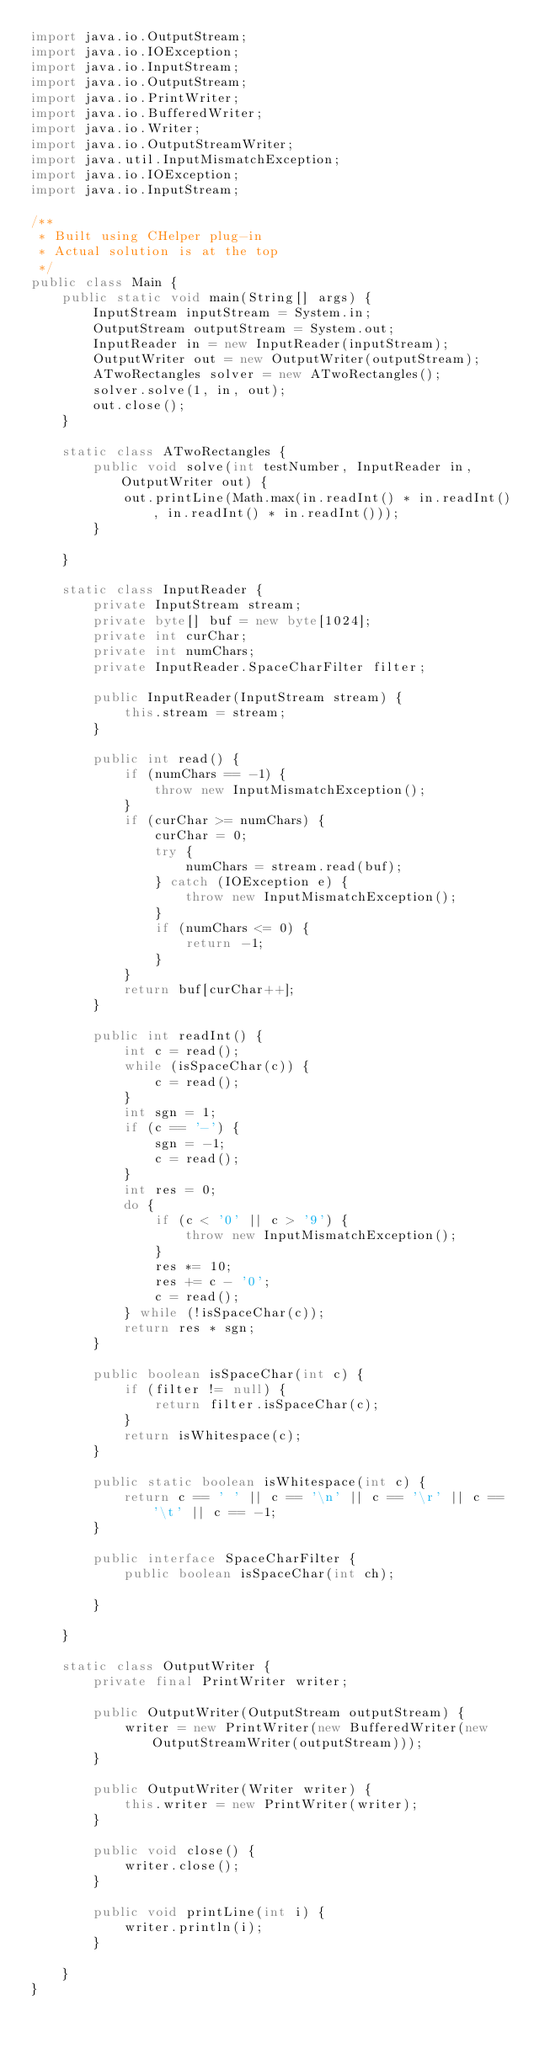<code> <loc_0><loc_0><loc_500><loc_500><_Java_>import java.io.OutputStream;
import java.io.IOException;
import java.io.InputStream;
import java.io.OutputStream;
import java.io.PrintWriter;
import java.io.BufferedWriter;
import java.io.Writer;
import java.io.OutputStreamWriter;
import java.util.InputMismatchException;
import java.io.IOException;
import java.io.InputStream;

/**
 * Built using CHelper plug-in
 * Actual solution is at the top
 */
public class Main {
    public static void main(String[] args) {
        InputStream inputStream = System.in;
        OutputStream outputStream = System.out;
        InputReader in = new InputReader(inputStream);
        OutputWriter out = new OutputWriter(outputStream);
        ATwoRectangles solver = new ATwoRectangles();
        solver.solve(1, in, out);
        out.close();
    }

    static class ATwoRectangles {
        public void solve(int testNumber, InputReader in, OutputWriter out) {
            out.printLine(Math.max(in.readInt() * in.readInt(), in.readInt() * in.readInt()));
        }

    }

    static class InputReader {
        private InputStream stream;
        private byte[] buf = new byte[1024];
        private int curChar;
        private int numChars;
        private InputReader.SpaceCharFilter filter;

        public InputReader(InputStream stream) {
            this.stream = stream;
        }

        public int read() {
            if (numChars == -1) {
                throw new InputMismatchException();
            }
            if (curChar >= numChars) {
                curChar = 0;
                try {
                    numChars = stream.read(buf);
                } catch (IOException e) {
                    throw new InputMismatchException();
                }
                if (numChars <= 0) {
                    return -1;
                }
            }
            return buf[curChar++];
        }

        public int readInt() {
            int c = read();
            while (isSpaceChar(c)) {
                c = read();
            }
            int sgn = 1;
            if (c == '-') {
                sgn = -1;
                c = read();
            }
            int res = 0;
            do {
                if (c < '0' || c > '9') {
                    throw new InputMismatchException();
                }
                res *= 10;
                res += c - '0';
                c = read();
            } while (!isSpaceChar(c));
            return res * sgn;
        }

        public boolean isSpaceChar(int c) {
            if (filter != null) {
                return filter.isSpaceChar(c);
            }
            return isWhitespace(c);
        }

        public static boolean isWhitespace(int c) {
            return c == ' ' || c == '\n' || c == '\r' || c == '\t' || c == -1;
        }

        public interface SpaceCharFilter {
            public boolean isSpaceChar(int ch);

        }

    }

    static class OutputWriter {
        private final PrintWriter writer;

        public OutputWriter(OutputStream outputStream) {
            writer = new PrintWriter(new BufferedWriter(new OutputStreamWriter(outputStream)));
        }

        public OutputWriter(Writer writer) {
            this.writer = new PrintWriter(writer);
        }

        public void close() {
            writer.close();
        }

        public void printLine(int i) {
            writer.println(i);
        }

    }
}

</code> 